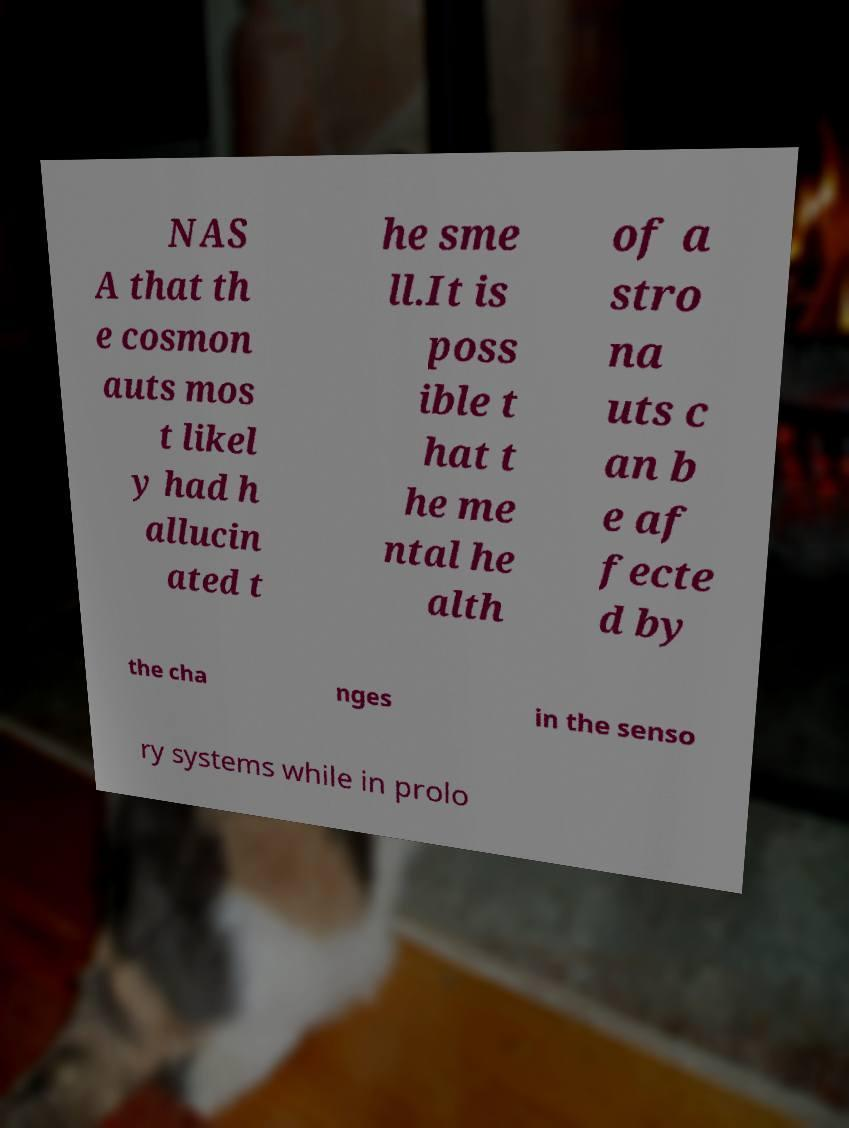I need the written content from this picture converted into text. Can you do that? NAS A that th e cosmon auts mos t likel y had h allucin ated t he sme ll.It is poss ible t hat t he me ntal he alth of a stro na uts c an b e af fecte d by the cha nges in the senso ry systems while in prolo 